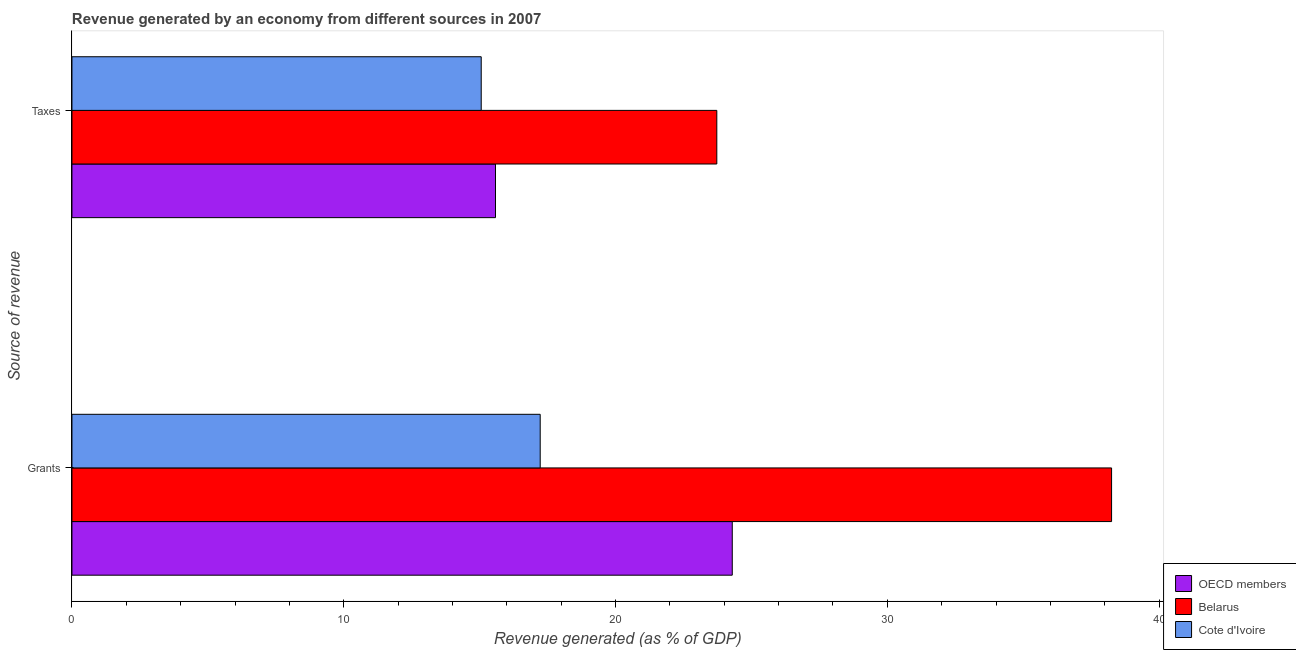How many groups of bars are there?
Offer a terse response. 2. Are the number of bars per tick equal to the number of legend labels?
Offer a terse response. Yes. How many bars are there on the 2nd tick from the bottom?
Your response must be concise. 3. What is the label of the 1st group of bars from the top?
Keep it short and to the point. Taxes. What is the revenue generated by grants in Belarus?
Offer a very short reply. 38.25. Across all countries, what is the maximum revenue generated by grants?
Keep it short and to the point. 38.25. Across all countries, what is the minimum revenue generated by taxes?
Provide a short and direct response. 15.06. In which country was the revenue generated by taxes maximum?
Your answer should be compact. Belarus. In which country was the revenue generated by grants minimum?
Your answer should be very brief. Cote d'Ivoire. What is the total revenue generated by taxes in the graph?
Give a very brief answer. 54.37. What is the difference between the revenue generated by grants in Cote d'Ivoire and that in OECD members?
Offer a very short reply. -7.07. What is the difference between the revenue generated by grants in Belarus and the revenue generated by taxes in OECD members?
Offer a very short reply. 22.67. What is the average revenue generated by taxes per country?
Your answer should be compact. 18.12. What is the difference between the revenue generated by taxes and revenue generated by grants in OECD members?
Make the answer very short. -8.71. In how many countries, is the revenue generated by taxes greater than 26 %?
Provide a succinct answer. 0. What is the ratio of the revenue generated by taxes in OECD members to that in Belarus?
Keep it short and to the point. 0.66. Is the revenue generated by taxes in Cote d'Ivoire less than that in Belarus?
Provide a short and direct response. Yes. What does the 1st bar from the bottom in Taxes represents?
Ensure brevity in your answer.  OECD members. Are all the bars in the graph horizontal?
Offer a very short reply. Yes. Are the values on the major ticks of X-axis written in scientific E-notation?
Provide a succinct answer. No. Where does the legend appear in the graph?
Your response must be concise. Bottom right. How many legend labels are there?
Your answer should be very brief. 3. How are the legend labels stacked?
Provide a succinct answer. Vertical. What is the title of the graph?
Your response must be concise. Revenue generated by an economy from different sources in 2007. What is the label or title of the X-axis?
Offer a terse response. Revenue generated (as % of GDP). What is the label or title of the Y-axis?
Ensure brevity in your answer.  Source of revenue. What is the Revenue generated (as % of GDP) of OECD members in Grants?
Your answer should be very brief. 24.3. What is the Revenue generated (as % of GDP) in Belarus in Grants?
Make the answer very short. 38.25. What is the Revenue generated (as % of GDP) in Cote d'Ivoire in Grants?
Keep it short and to the point. 17.23. What is the Revenue generated (as % of GDP) of OECD members in Taxes?
Give a very brief answer. 15.58. What is the Revenue generated (as % of GDP) in Belarus in Taxes?
Make the answer very short. 23.73. What is the Revenue generated (as % of GDP) of Cote d'Ivoire in Taxes?
Your response must be concise. 15.06. Across all Source of revenue, what is the maximum Revenue generated (as % of GDP) in OECD members?
Make the answer very short. 24.3. Across all Source of revenue, what is the maximum Revenue generated (as % of GDP) in Belarus?
Provide a short and direct response. 38.25. Across all Source of revenue, what is the maximum Revenue generated (as % of GDP) of Cote d'Ivoire?
Your answer should be compact. 17.23. Across all Source of revenue, what is the minimum Revenue generated (as % of GDP) in OECD members?
Provide a short and direct response. 15.58. Across all Source of revenue, what is the minimum Revenue generated (as % of GDP) of Belarus?
Make the answer very short. 23.73. Across all Source of revenue, what is the minimum Revenue generated (as % of GDP) in Cote d'Ivoire?
Your response must be concise. 15.06. What is the total Revenue generated (as % of GDP) of OECD members in the graph?
Ensure brevity in your answer.  39.88. What is the total Revenue generated (as % of GDP) of Belarus in the graph?
Keep it short and to the point. 61.98. What is the total Revenue generated (as % of GDP) of Cote d'Ivoire in the graph?
Your response must be concise. 32.29. What is the difference between the Revenue generated (as % of GDP) of OECD members in Grants and that in Taxes?
Provide a short and direct response. 8.71. What is the difference between the Revenue generated (as % of GDP) of Belarus in Grants and that in Taxes?
Provide a short and direct response. 14.52. What is the difference between the Revenue generated (as % of GDP) in Cote d'Ivoire in Grants and that in Taxes?
Offer a terse response. 2.17. What is the difference between the Revenue generated (as % of GDP) in OECD members in Grants and the Revenue generated (as % of GDP) in Belarus in Taxes?
Your response must be concise. 0.57. What is the difference between the Revenue generated (as % of GDP) in OECD members in Grants and the Revenue generated (as % of GDP) in Cote d'Ivoire in Taxes?
Ensure brevity in your answer.  9.24. What is the difference between the Revenue generated (as % of GDP) of Belarus in Grants and the Revenue generated (as % of GDP) of Cote d'Ivoire in Taxes?
Provide a succinct answer. 23.19. What is the average Revenue generated (as % of GDP) in OECD members per Source of revenue?
Provide a short and direct response. 19.94. What is the average Revenue generated (as % of GDP) of Belarus per Source of revenue?
Ensure brevity in your answer.  30.99. What is the average Revenue generated (as % of GDP) of Cote d'Ivoire per Source of revenue?
Ensure brevity in your answer.  16.14. What is the difference between the Revenue generated (as % of GDP) in OECD members and Revenue generated (as % of GDP) in Belarus in Grants?
Keep it short and to the point. -13.96. What is the difference between the Revenue generated (as % of GDP) of OECD members and Revenue generated (as % of GDP) of Cote d'Ivoire in Grants?
Your answer should be compact. 7.07. What is the difference between the Revenue generated (as % of GDP) in Belarus and Revenue generated (as % of GDP) in Cote d'Ivoire in Grants?
Offer a very short reply. 21.02. What is the difference between the Revenue generated (as % of GDP) of OECD members and Revenue generated (as % of GDP) of Belarus in Taxes?
Provide a short and direct response. -8.14. What is the difference between the Revenue generated (as % of GDP) of OECD members and Revenue generated (as % of GDP) of Cote d'Ivoire in Taxes?
Keep it short and to the point. 0.53. What is the difference between the Revenue generated (as % of GDP) of Belarus and Revenue generated (as % of GDP) of Cote d'Ivoire in Taxes?
Offer a terse response. 8.67. What is the ratio of the Revenue generated (as % of GDP) in OECD members in Grants to that in Taxes?
Provide a short and direct response. 1.56. What is the ratio of the Revenue generated (as % of GDP) in Belarus in Grants to that in Taxes?
Your answer should be very brief. 1.61. What is the ratio of the Revenue generated (as % of GDP) of Cote d'Ivoire in Grants to that in Taxes?
Give a very brief answer. 1.14. What is the difference between the highest and the second highest Revenue generated (as % of GDP) of OECD members?
Make the answer very short. 8.71. What is the difference between the highest and the second highest Revenue generated (as % of GDP) in Belarus?
Your answer should be very brief. 14.52. What is the difference between the highest and the second highest Revenue generated (as % of GDP) in Cote d'Ivoire?
Offer a very short reply. 2.17. What is the difference between the highest and the lowest Revenue generated (as % of GDP) of OECD members?
Make the answer very short. 8.71. What is the difference between the highest and the lowest Revenue generated (as % of GDP) in Belarus?
Provide a succinct answer. 14.52. What is the difference between the highest and the lowest Revenue generated (as % of GDP) in Cote d'Ivoire?
Keep it short and to the point. 2.17. 